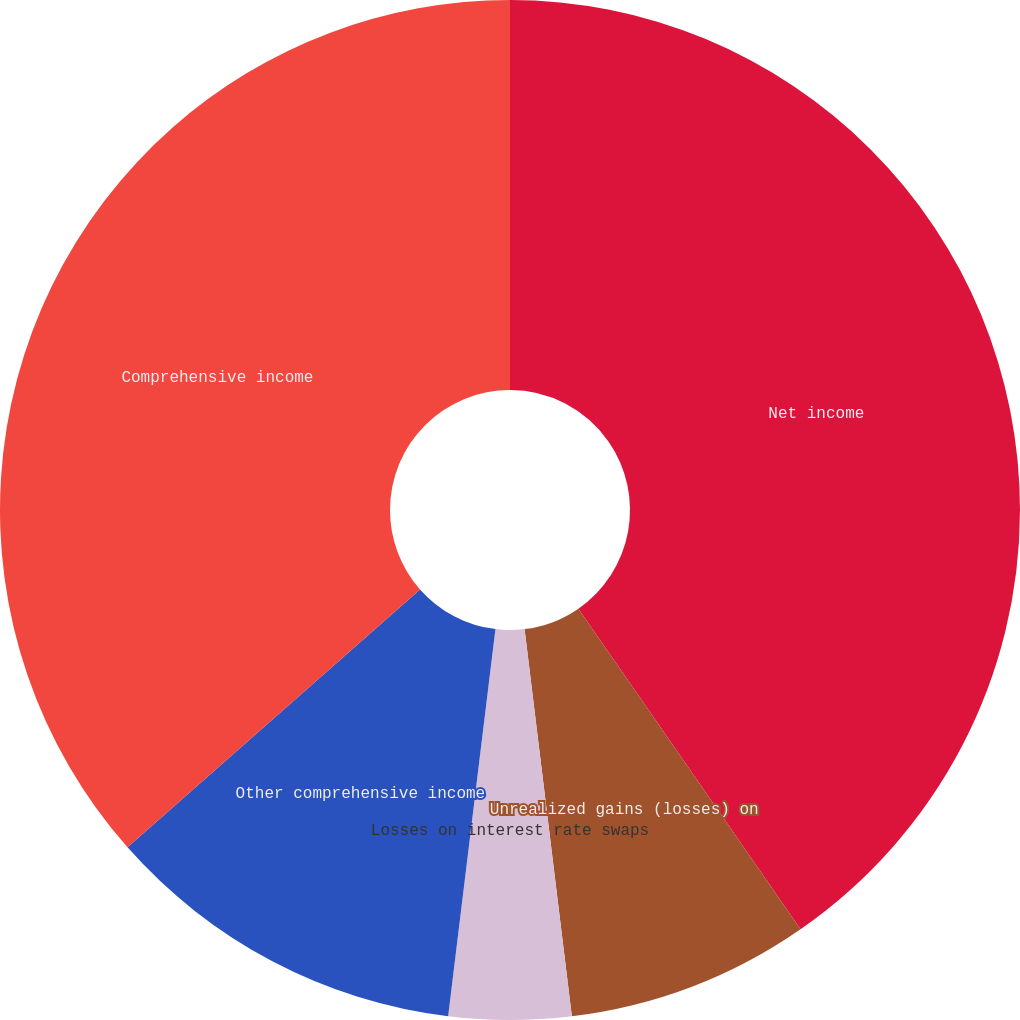<chart> <loc_0><loc_0><loc_500><loc_500><pie_chart><fcel>Net income<fcel>Unrealized gains (losses) on<fcel>Losses on interest rate swaps<fcel>Other comprehensive income<fcel>Comprehensive income<nl><fcel>40.35%<fcel>7.71%<fcel>3.87%<fcel>11.56%<fcel>36.5%<nl></chart> 